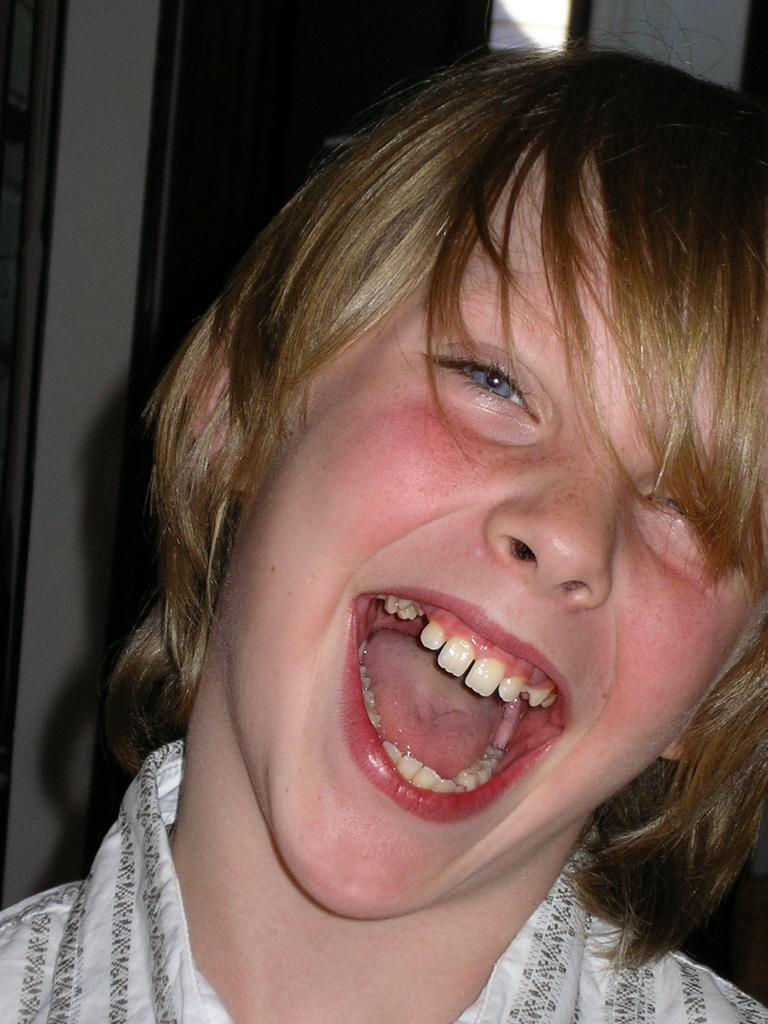Who or what is present in the image? There is a person in the image. What is the person doing or expressing? The person is smiling. What can be seen in the background of the image? There is a door in the background of the image. What type of glove is the person wearing in the image? There is no glove visible in the image; the person is not wearing any gloves. What does the caption say about the person's smile in the image? There is no caption present in the image, so we cannot determine what it might say about the person's smile. 